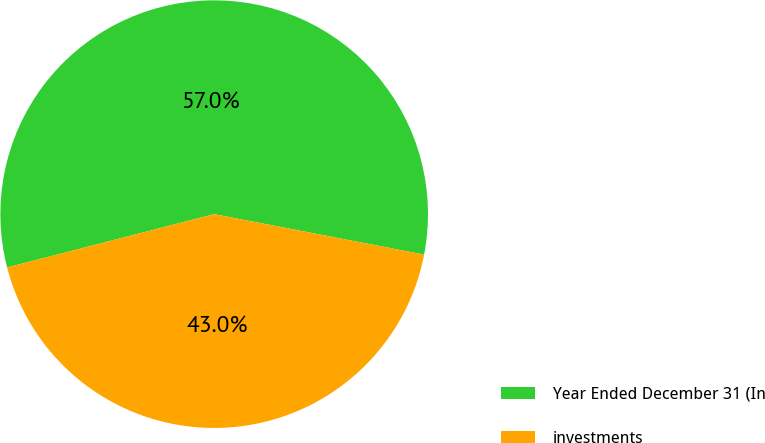<chart> <loc_0><loc_0><loc_500><loc_500><pie_chart><fcel>Year Ended December 31 (In<fcel>investments<nl><fcel>57.04%<fcel>42.96%<nl></chart> 